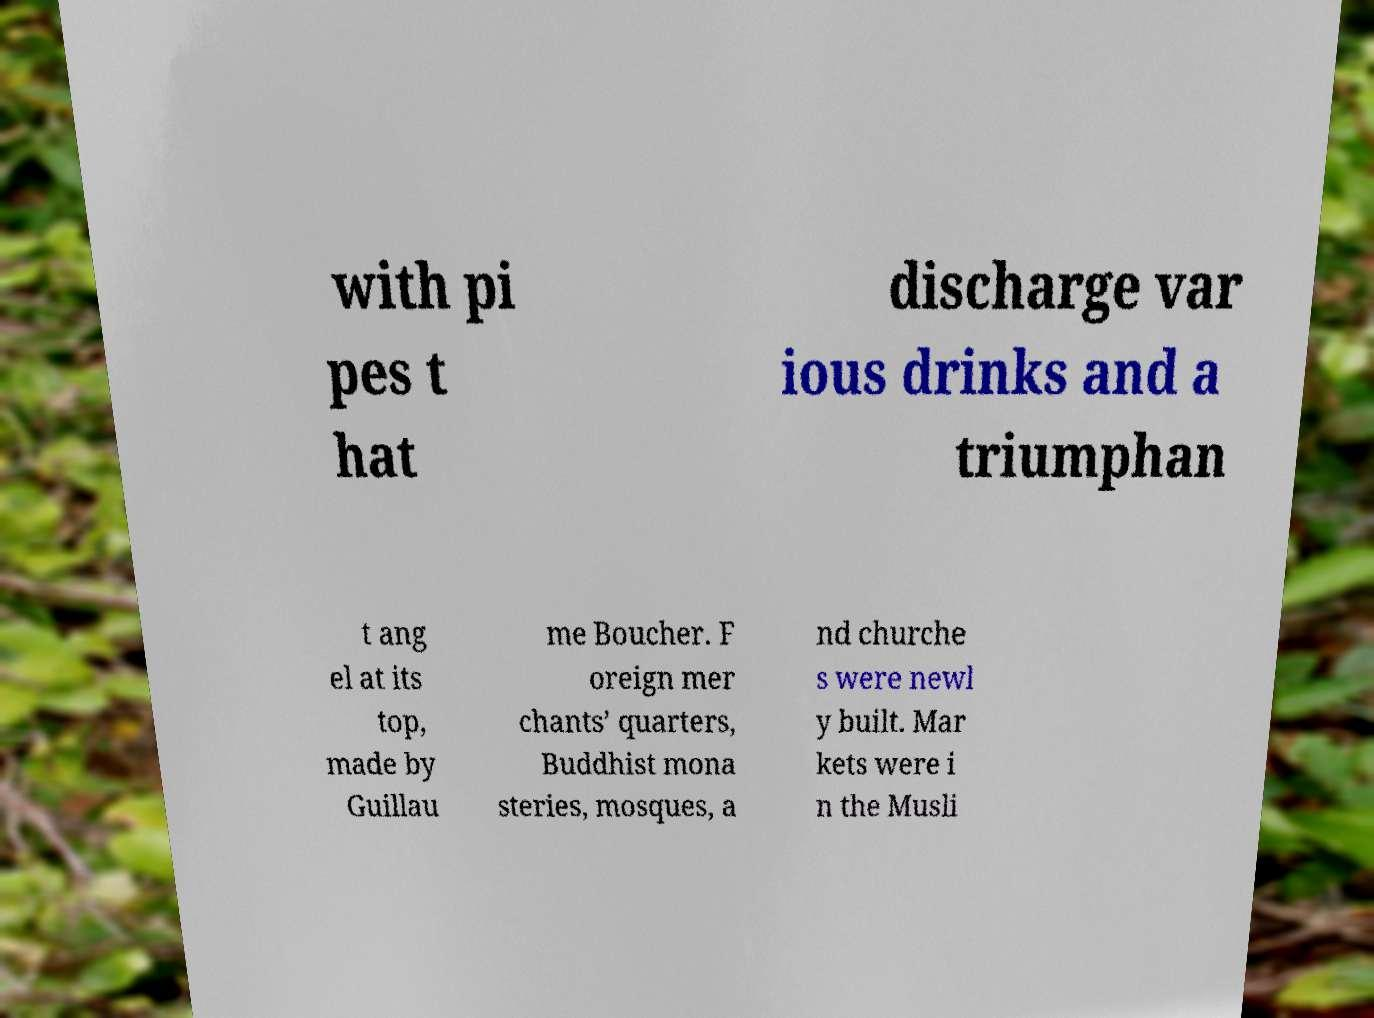What messages or text are displayed in this image? I need them in a readable, typed format. with pi pes t hat discharge var ious drinks and a triumphan t ang el at its top, made by Guillau me Boucher. F oreign mer chants’ quarters, Buddhist mona steries, mosques, a nd churche s were newl y built. Mar kets were i n the Musli 